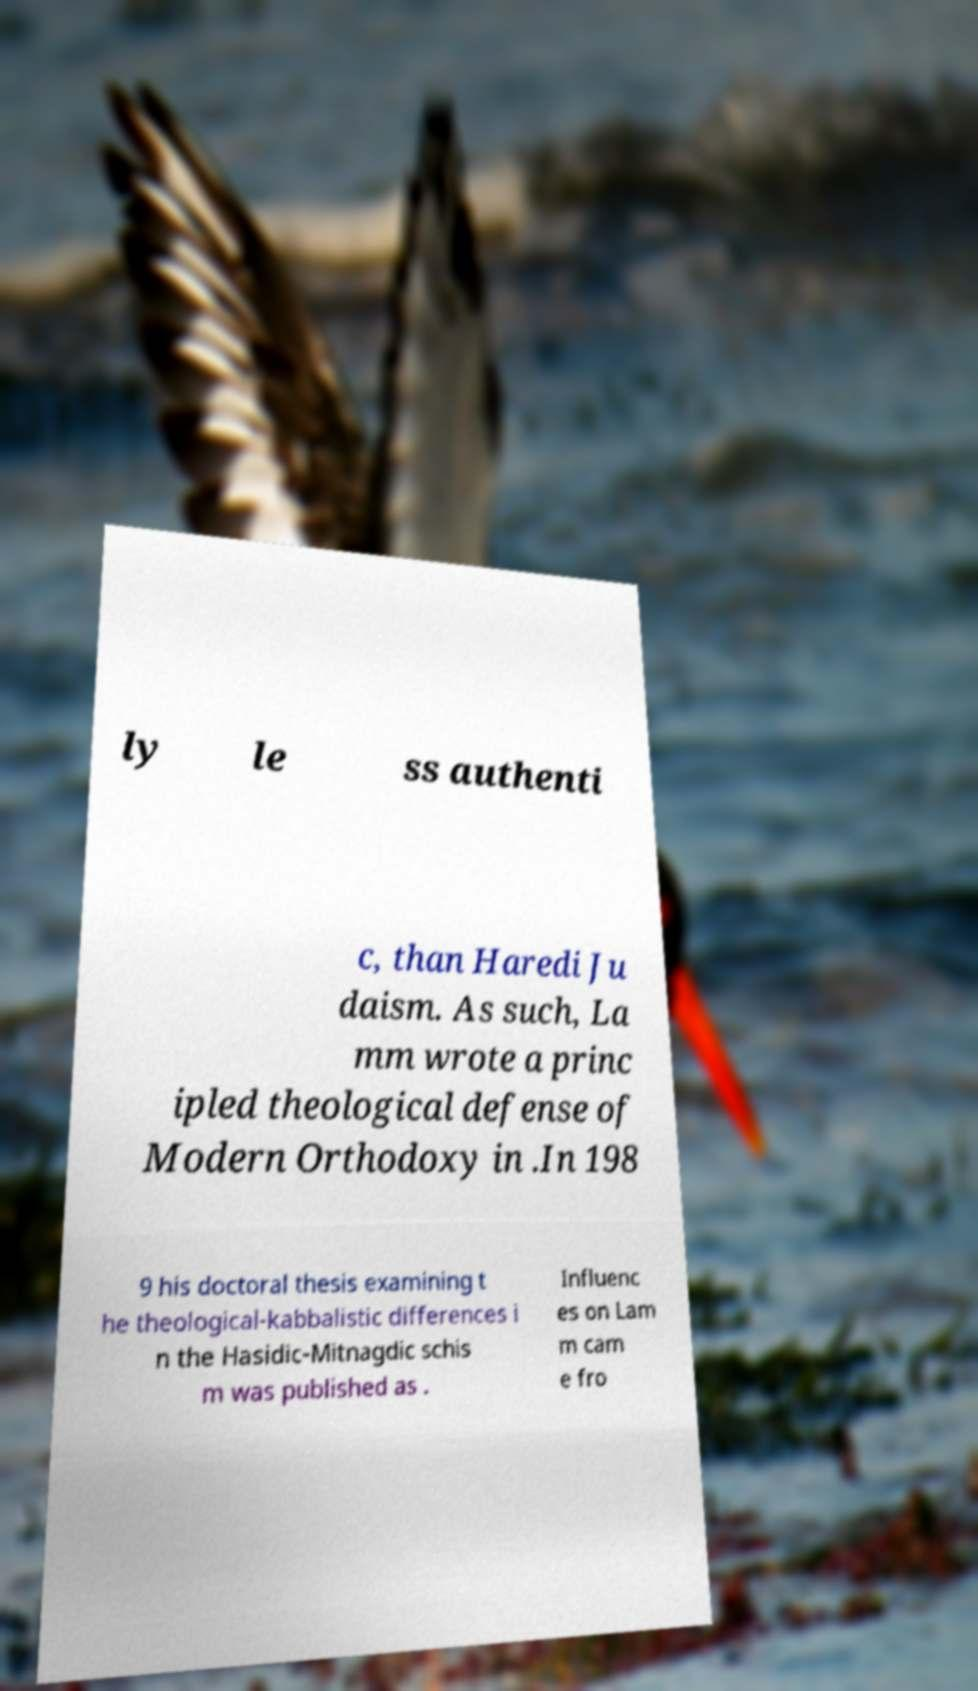For documentation purposes, I need the text within this image transcribed. Could you provide that? ly le ss authenti c, than Haredi Ju daism. As such, La mm wrote a princ ipled theological defense of Modern Orthodoxy in .In 198 9 his doctoral thesis examining t he theological-kabbalistic differences i n the Hasidic-Mitnagdic schis m was published as . Influenc es on Lam m cam e fro 